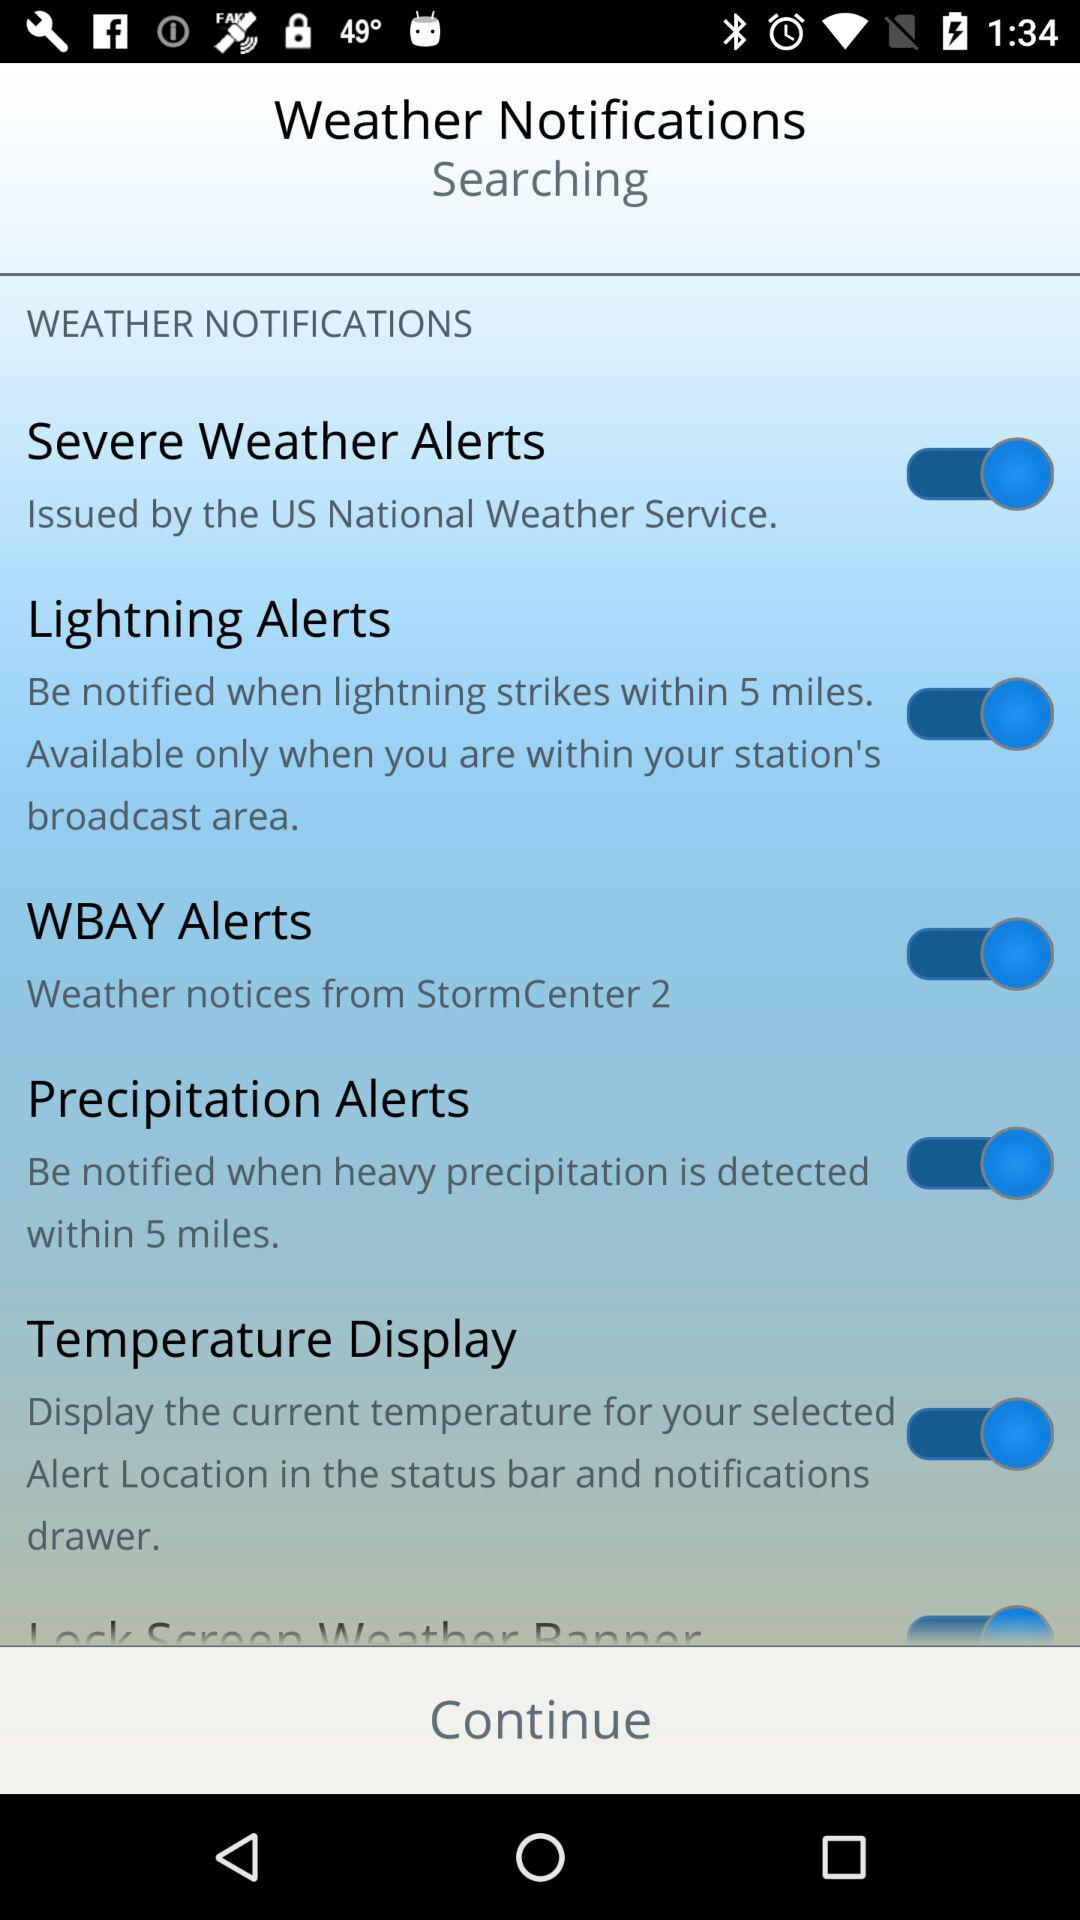What is the description of precipitation alerts? The description of precipitation alerts is "Be notified when heavy precipitation is detected within 5 miles". 